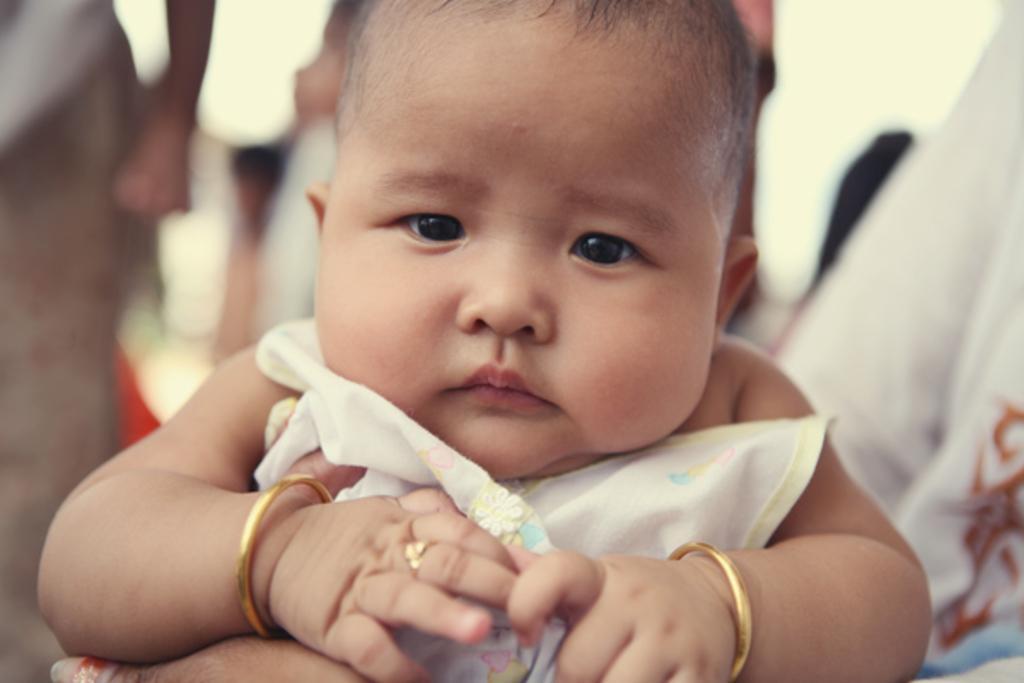Describe this image in one or two sentences. In the center of the image there is a baby. 